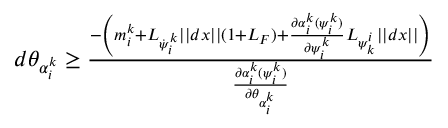<formula> <loc_0><loc_0><loc_500><loc_500>\begin{array} { r } { d \theta _ { \alpha _ { i } ^ { k } } \geq \frac { - \left ( m _ { i } ^ { k } + L _ { \dot { \psi } _ { i } ^ { k } } | | d x | | ( 1 + L _ { F } ) + \frac { \partial \alpha _ { i } ^ { k } ( \psi _ { i } ^ { k } ) } { \partial \psi _ { i } ^ { k } } L _ { \psi _ { k } ^ { i } } | | d x | | \right ) } { \frac { \partial \alpha _ { i } ^ { k } ( \psi _ { i } ^ { k } ) } { \partial \theta _ { \alpha _ { i } ^ { k } } } } } \end{array}</formula> 